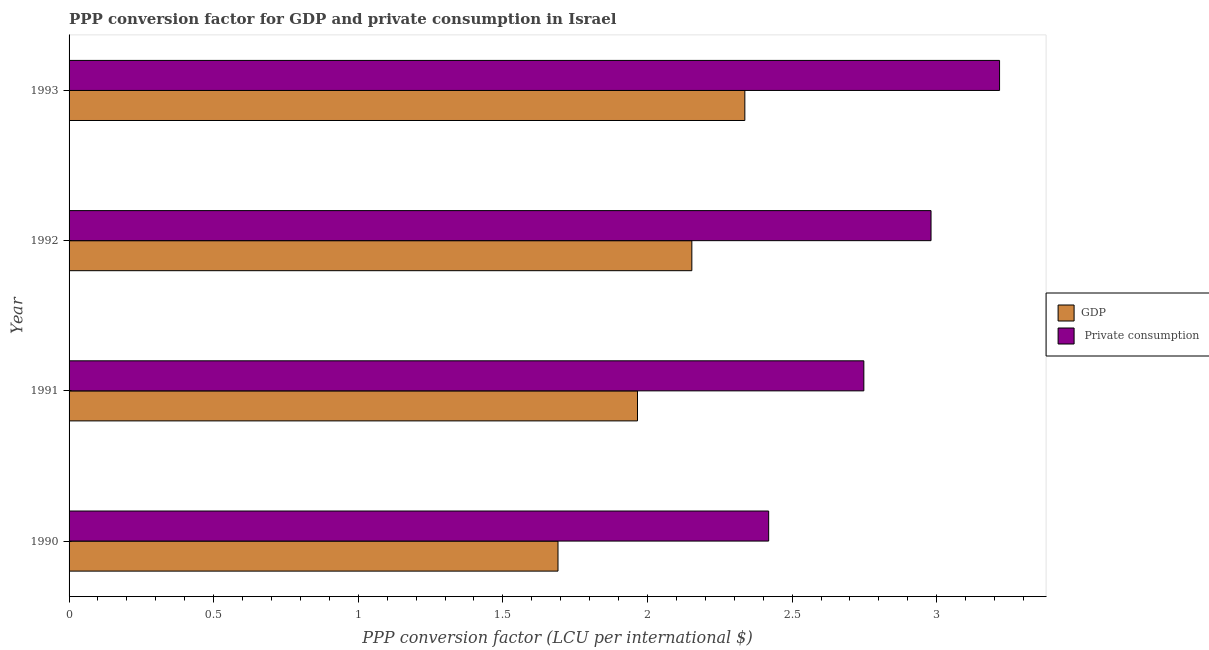How many different coloured bars are there?
Your answer should be compact. 2. Are the number of bars per tick equal to the number of legend labels?
Provide a short and direct response. Yes. Are the number of bars on each tick of the Y-axis equal?
Keep it short and to the point. Yes. How many bars are there on the 1st tick from the bottom?
Offer a very short reply. 2. In how many cases, is the number of bars for a given year not equal to the number of legend labels?
Your answer should be compact. 0. What is the ppp conversion factor for private consumption in 1990?
Offer a terse response. 2.42. Across all years, what is the maximum ppp conversion factor for private consumption?
Ensure brevity in your answer.  3.22. Across all years, what is the minimum ppp conversion factor for gdp?
Provide a short and direct response. 1.69. In which year was the ppp conversion factor for private consumption minimum?
Ensure brevity in your answer.  1990. What is the total ppp conversion factor for gdp in the graph?
Make the answer very short. 8.15. What is the difference between the ppp conversion factor for gdp in 1990 and that in 1993?
Keep it short and to the point. -0.65. What is the difference between the ppp conversion factor for gdp in 1992 and the ppp conversion factor for private consumption in 1993?
Give a very brief answer. -1.06. What is the average ppp conversion factor for private consumption per year?
Your response must be concise. 2.84. In the year 1992, what is the difference between the ppp conversion factor for private consumption and ppp conversion factor for gdp?
Make the answer very short. 0.83. In how many years, is the ppp conversion factor for gdp greater than 0.2 LCU?
Provide a short and direct response. 4. What is the ratio of the ppp conversion factor for private consumption in 1992 to that in 1993?
Keep it short and to the point. 0.93. Is the ppp conversion factor for private consumption in 1990 less than that in 1992?
Give a very brief answer. Yes. What is the difference between the highest and the second highest ppp conversion factor for gdp?
Offer a terse response. 0.18. What is the difference between the highest and the lowest ppp conversion factor for gdp?
Your response must be concise. 0.65. Is the sum of the ppp conversion factor for gdp in 1991 and 1993 greater than the maximum ppp conversion factor for private consumption across all years?
Provide a succinct answer. Yes. What does the 2nd bar from the top in 1992 represents?
Make the answer very short. GDP. What does the 2nd bar from the bottom in 1993 represents?
Make the answer very short.  Private consumption. Are the values on the major ticks of X-axis written in scientific E-notation?
Offer a very short reply. No. Where does the legend appear in the graph?
Offer a very short reply. Center right. How many legend labels are there?
Give a very brief answer. 2. How are the legend labels stacked?
Give a very brief answer. Vertical. What is the title of the graph?
Offer a very short reply. PPP conversion factor for GDP and private consumption in Israel. What is the label or title of the X-axis?
Keep it short and to the point. PPP conversion factor (LCU per international $). What is the label or title of the Y-axis?
Your answer should be very brief. Year. What is the PPP conversion factor (LCU per international $) in GDP in 1990?
Your response must be concise. 1.69. What is the PPP conversion factor (LCU per international $) of  Private consumption in 1990?
Provide a short and direct response. 2.42. What is the PPP conversion factor (LCU per international $) in GDP in 1991?
Your answer should be very brief. 1.97. What is the PPP conversion factor (LCU per international $) in  Private consumption in 1991?
Offer a terse response. 2.75. What is the PPP conversion factor (LCU per international $) in GDP in 1992?
Make the answer very short. 2.15. What is the PPP conversion factor (LCU per international $) of  Private consumption in 1992?
Give a very brief answer. 2.98. What is the PPP conversion factor (LCU per international $) in GDP in 1993?
Your answer should be compact. 2.34. What is the PPP conversion factor (LCU per international $) in  Private consumption in 1993?
Give a very brief answer. 3.22. Across all years, what is the maximum PPP conversion factor (LCU per international $) in GDP?
Your response must be concise. 2.34. Across all years, what is the maximum PPP conversion factor (LCU per international $) of  Private consumption?
Ensure brevity in your answer.  3.22. Across all years, what is the minimum PPP conversion factor (LCU per international $) in GDP?
Offer a terse response. 1.69. Across all years, what is the minimum PPP conversion factor (LCU per international $) in  Private consumption?
Your answer should be very brief. 2.42. What is the total PPP conversion factor (LCU per international $) of GDP in the graph?
Your response must be concise. 8.15. What is the total PPP conversion factor (LCU per international $) of  Private consumption in the graph?
Ensure brevity in your answer.  11.37. What is the difference between the PPP conversion factor (LCU per international $) in GDP in 1990 and that in 1991?
Ensure brevity in your answer.  -0.27. What is the difference between the PPP conversion factor (LCU per international $) of  Private consumption in 1990 and that in 1991?
Make the answer very short. -0.33. What is the difference between the PPP conversion factor (LCU per international $) of GDP in 1990 and that in 1992?
Your response must be concise. -0.46. What is the difference between the PPP conversion factor (LCU per international $) in  Private consumption in 1990 and that in 1992?
Your answer should be very brief. -0.56. What is the difference between the PPP conversion factor (LCU per international $) in GDP in 1990 and that in 1993?
Provide a short and direct response. -0.65. What is the difference between the PPP conversion factor (LCU per international $) in  Private consumption in 1990 and that in 1993?
Ensure brevity in your answer.  -0.8. What is the difference between the PPP conversion factor (LCU per international $) in GDP in 1991 and that in 1992?
Your response must be concise. -0.19. What is the difference between the PPP conversion factor (LCU per international $) in  Private consumption in 1991 and that in 1992?
Provide a succinct answer. -0.23. What is the difference between the PPP conversion factor (LCU per international $) in GDP in 1991 and that in 1993?
Make the answer very short. -0.37. What is the difference between the PPP conversion factor (LCU per international $) in  Private consumption in 1991 and that in 1993?
Give a very brief answer. -0.47. What is the difference between the PPP conversion factor (LCU per international $) in GDP in 1992 and that in 1993?
Offer a very short reply. -0.18. What is the difference between the PPP conversion factor (LCU per international $) of  Private consumption in 1992 and that in 1993?
Your answer should be compact. -0.24. What is the difference between the PPP conversion factor (LCU per international $) in GDP in 1990 and the PPP conversion factor (LCU per international $) in  Private consumption in 1991?
Make the answer very short. -1.06. What is the difference between the PPP conversion factor (LCU per international $) of GDP in 1990 and the PPP conversion factor (LCU per international $) of  Private consumption in 1992?
Your answer should be compact. -1.29. What is the difference between the PPP conversion factor (LCU per international $) in GDP in 1990 and the PPP conversion factor (LCU per international $) in  Private consumption in 1993?
Provide a succinct answer. -1.53. What is the difference between the PPP conversion factor (LCU per international $) of GDP in 1991 and the PPP conversion factor (LCU per international $) of  Private consumption in 1992?
Provide a short and direct response. -1.01. What is the difference between the PPP conversion factor (LCU per international $) of GDP in 1991 and the PPP conversion factor (LCU per international $) of  Private consumption in 1993?
Give a very brief answer. -1.25. What is the difference between the PPP conversion factor (LCU per international $) of GDP in 1992 and the PPP conversion factor (LCU per international $) of  Private consumption in 1993?
Make the answer very short. -1.06. What is the average PPP conversion factor (LCU per international $) of GDP per year?
Your response must be concise. 2.04. What is the average PPP conversion factor (LCU per international $) of  Private consumption per year?
Offer a terse response. 2.84. In the year 1990, what is the difference between the PPP conversion factor (LCU per international $) in GDP and PPP conversion factor (LCU per international $) in  Private consumption?
Offer a very short reply. -0.73. In the year 1991, what is the difference between the PPP conversion factor (LCU per international $) of GDP and PPP conversion factor (LCU per international $) of  Private consumption?
Ensure brevity in your answer.  -0.78. In the year 1992, what is the difference between the PPP conversion factor (LCU per international $) of GDP and PPP conversion factor (LCU per international $) of  Private consumption?
Offer a terse response. -0.83. In the year 1993, what is the difference between the PPP conversion factor (LCU per international $) in GDP and PPP conversion factor (LCU per international $) in  Private consumption?
Provide a succinct answer. -0.88. What is the ratio of the PPP conversion factor (LCU per international $) in GDP in 1990 to that in 1991?
Your response must be concise. 0.86. What is the ratio of the PPP conversion factor (LCU per international $) of  Private consumption in 1990 to that in 1991?
Offer a terse response. 0.88. What is the ratio of the PPP conversion factor (LCU per international $) in GDP in 1990 to that in 1992?
Offer a very short reply. 0.79. What is the ratio of the PPP conversion factor (LCU per international $) in  Private consumption in 1990 to that in 1992?
Your answer should be very brief. 0.81. What is the ratio of the PPP conversion factor (LCU per international $) in GDP in 1990 to that in 1993?
Your answer should be compact. 0.72. What is the ratio of the PPP conversion factor (LCU per international $) of  Private consumption in 1990 to that in 1993?
Provide a short and direct response. 0.75. What is the ratio of the PPP conversion factor (LCU per international $) of GDP in 1991 to that in 1992?
Your response must be concise. 0.91. What is the ratio of the PPP conversion factor (LCU per international $) in  Private consumption in 1991 to that in 1992?
Your answer should be very brief. 0.92. What is the ratio of the PPP conversion factor (LCU per international $) of GDP in 1991 to that in 1993?
Keep it short and to the point. 0.84. What is the ratio of the PPP conversion factor (LCU per international $) of  Private consumption in 1991 to that in 1993?
Make the answer very short. 0.85. What is the ratio of the PPP conversion factor (LCU per international $) of GDP in 1992 to that in 1993?
Ensure brevity in your answer.  0.92. What is the ratio of the PPP conversion factor (LCU per international $) in  Private consumption in 1992 to that in 1993?
Your answer should be compact. 0.93. What is the difference between the highest and the second highest PPP conversion factor (LCU per international $) in GDP?
Offer a very short reply. 0.18. What is the difference between the highest and the second highest PPP conversion factor (LCU per international $) of  Private consumption?
Your answer should be very brief. 0.24. What is the difference between the highest and the lowest PPP conversion factor (LCU per international $) of GDP?
Your answer should be compact. 0.65. What is the difference between the highest and the lowest PPP conversion factor (LCU per international $) of  Private consumption?
Give a very brief answer. 0.8. 